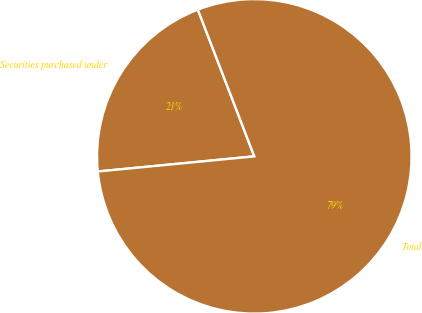<chart> <loc_0><loc_0><loc_500><loc_500><pie_chart><fcel>Securities purchased under<fcel>Total<nl><fcel>20.69%<fcel>79.31%<nl></chart> 